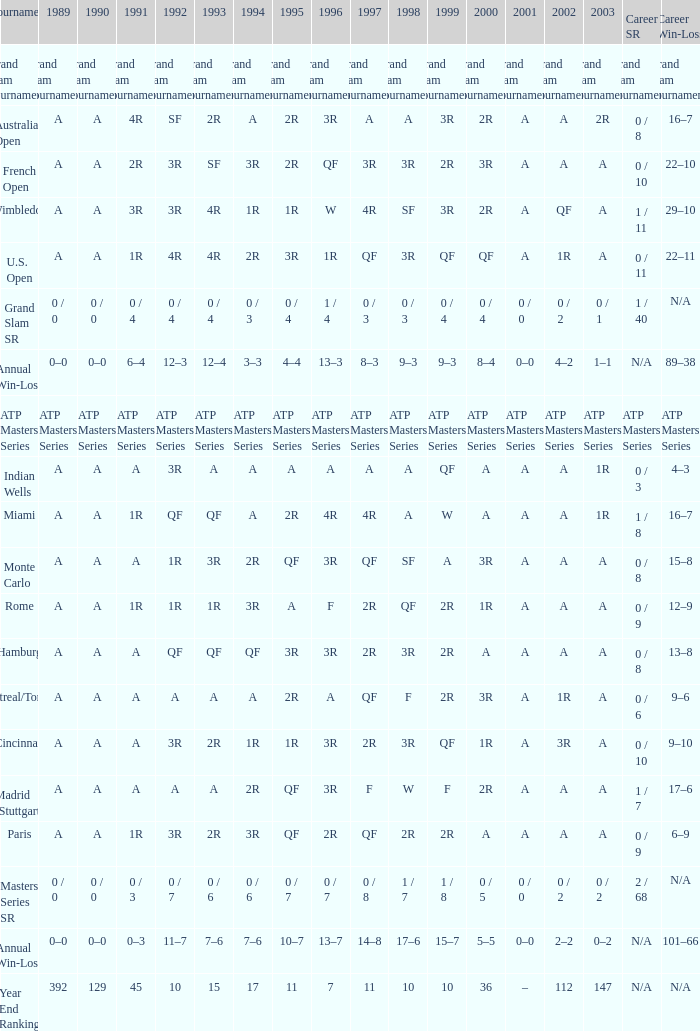What was the value in 1995 for A in 2000 at the Indian Wells tournament? A. 